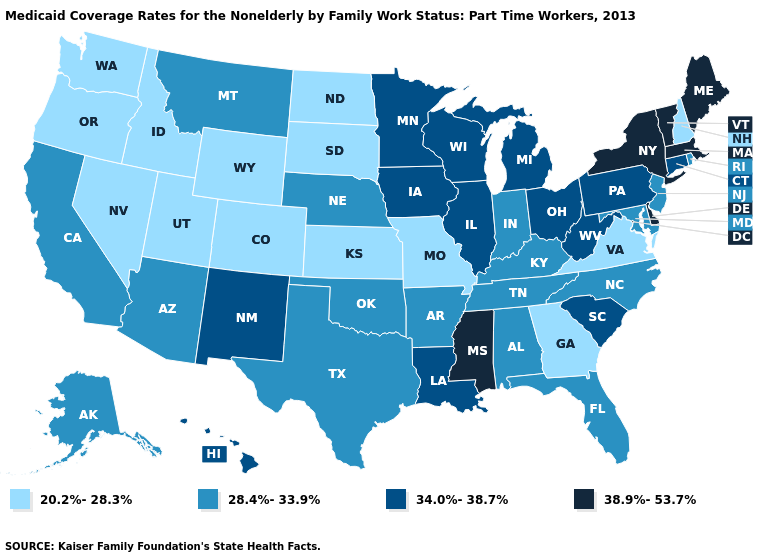What is the value of Maine?
Quick response, please. 38.9%-53.7%. Name the states that have a value in the range 38.9%-53.7%?
Answer briefly. Delaware, Maine, Massachusetts, Mississippi, New York, Vermont. Among the states that border Maryland , does Delaware have the highest value?
Give a very brief answer. Yes. What is the value of Oklahoma?
Give a very brief answer. 28.4%-33.9%. What is the lowest value in the USA?
Write a very short answer. 20.2%-28.3%. Which states hav the highest value in the West?
Give a very brief answer. Hawaii, New Mexico. Is the legend a continuous bar?
Concise answer only. No. Which states hav the highest value in the West?
Give a very brief answer. Hawaii, New Mexico. Among the states that border Vermont , which have the lowest value?
Concise answer only. New Hampshire. What is the value of Nevada?
Write a very short answer. 20.2%-28.3%. Name the states that have a value in the range 28.4%-33.9%?
Be succinct. Alabama, Alaska, Arizona, Arkansas, California, Florida, Indiana, Kentucky, Maryland, Montana, Nebraska, New Jersey, North Carolina, Oklahoma, Rhode Island, Tennessee, Texas. Does Kansas have the highest value in the USA?
Answer briefly. No. Name the states that have a value in the range 28.4%-33.9%?
Keep it brief. Alabama, Alaska, Arizona, Arkansas, California, Florida, Indiana, Kentucky, Maryland, Montana, Nebraska, New Jersey, North Carolina, Oklahoma, Rhode Island, Tennessee, Texas. Which states hav the highest value in the West?
Concise answer only. Hawaii, New Mexico. 